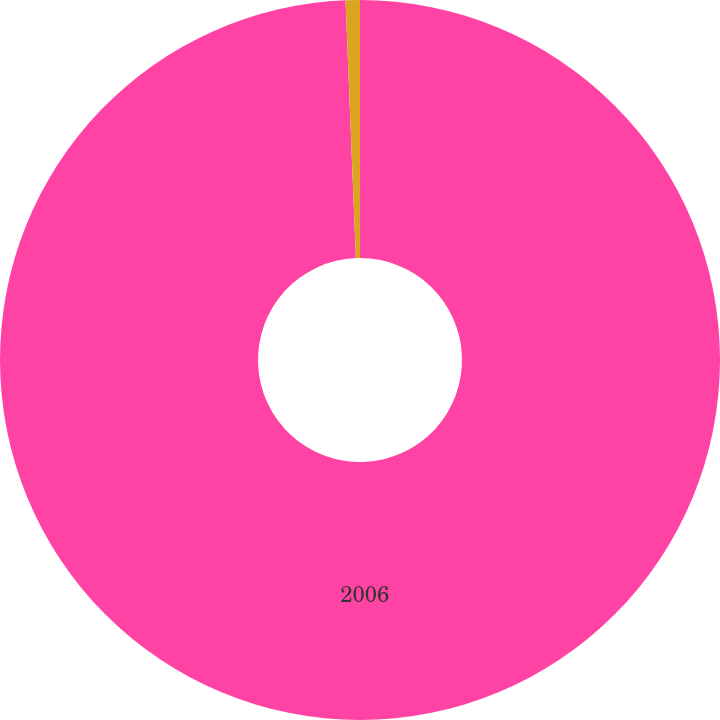<chart> <loc_0><loc_0><loc_500><loc_500><pie_chart><fcel>2006<fcel>Unnamed: 1<nl><fcel>99.36%<fcel>0.64%<nl></chart> 